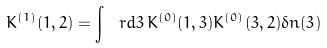<formula> <loc_0><loc_0><loc_500><loc_500>K ^ { ( 1 ) } ( 1 , 2 ) = \int \ r d 3 \, K ^ { ( 0 ) } ( 1 , 3 ) K ^ { ( 0 ) } ( 3 , 2 ) \delta n ( 3 )</formula> 